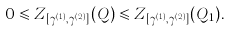<formula> <loc_0><loc_0><loc_500><loc_500>0 \leqslant Z _ { [ \gamma ^ { ( 1 ) } , \gamma ^ { ( 2 ) } ] } ( Q ) \leqslant Z _ { [ \gamma ^ { ( 1 ) } , \gamma ^ { ( 2 ) } ] } ( Q _ { 1 } ) .</formula> 